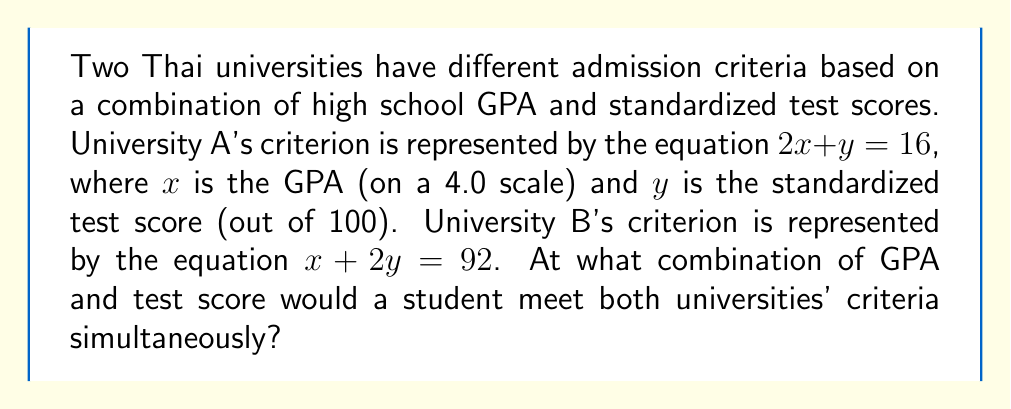What is the answer to this math problem? To find the point where a student would meet both universities' criteria simultaneously, we need to find the intersection point of the two lines representing their admission criteria. Let's solve this step-by-step:

1) We have two equations:
   University A: $2x + y = 16$
   University B: $x + 2y = 92$

2) We can solve this system of equations using substitution method. Let's solve the first equation for $y$:
   $y = 16 - 2x$

3) Now substitute this expression for $y$ into the second equation:
   $x + 2(16 - 2x) = 92$

4) Simplify:
   $x + 32 - 4x = 92$
   $-3x + 32 = 92$

5) Subtract 32 from both sides:
   $-3x = 60$

6) Divide both sides by -3:
   $x = -20$

7) Now that we know $x$, we can substitute it back into either of the original equations to find $y$. Let's use the first equation:
   $2(-20) + y = 16$
   $-40 + y = 16$
   $y = 56$

8) Therefore, the intersection point is $(-20, 56)$. However, this doesn't make sense in the context of our problem because GPA can't be negative and can't exceed 4.0.

9) Let's check our work by solving for $y$ first instead:
   From the first equation: $y = 16 - 2x$
   From the second equation: $y = 46 - \frac{1}{2}x$

   Setting these equal:
   $16 - 2x = 46 - \frac{1}{2}x$
   $-2x + \frac{1}{2}x = 46 - 16$
   $-\frac{3}{2}x = 30$
   $x = -20$

   This confirms our previous result.

10) Since our result doesn't make sense in the context of college admissions, we should conclude that there is no valid intersection point. This means there is no combination of GPA and test score that simultaneously satisfies both universities' criteria.
Answer: There is no valid intersection point. The mathematical solution $(-20, 56)$ is not meaningful in the context of GPA and test scores, as GPA cannot be negative or exceed 4.0, and test scores are typically between 0 and 100. 